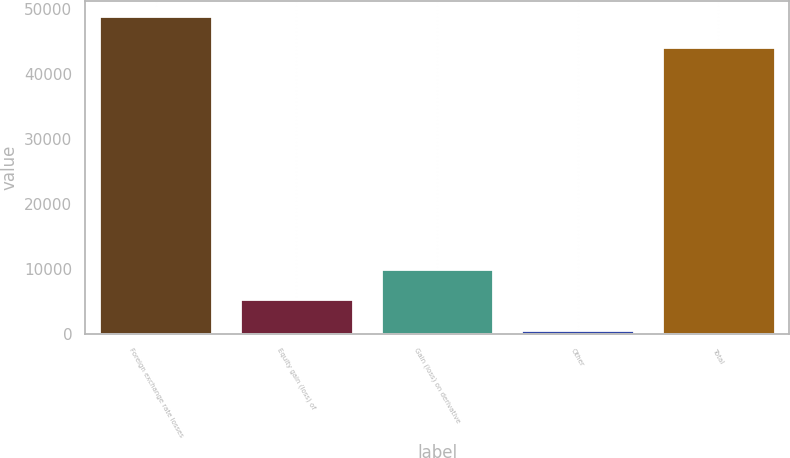Convert chart to OTSL. <chart><loc_0><loc_0><loc_500><loc_500><bar_chart><fcel>Foreign exchange rate losses<fcel>Equity gain (loss) of<fcel>Gain (loss) on derivative<fcel>Other<fcel>Total<nl><fcel>48823.9<fcel>5315.9<fcel>9961.8<fcel>670<fcel>44178<nl></chart> 